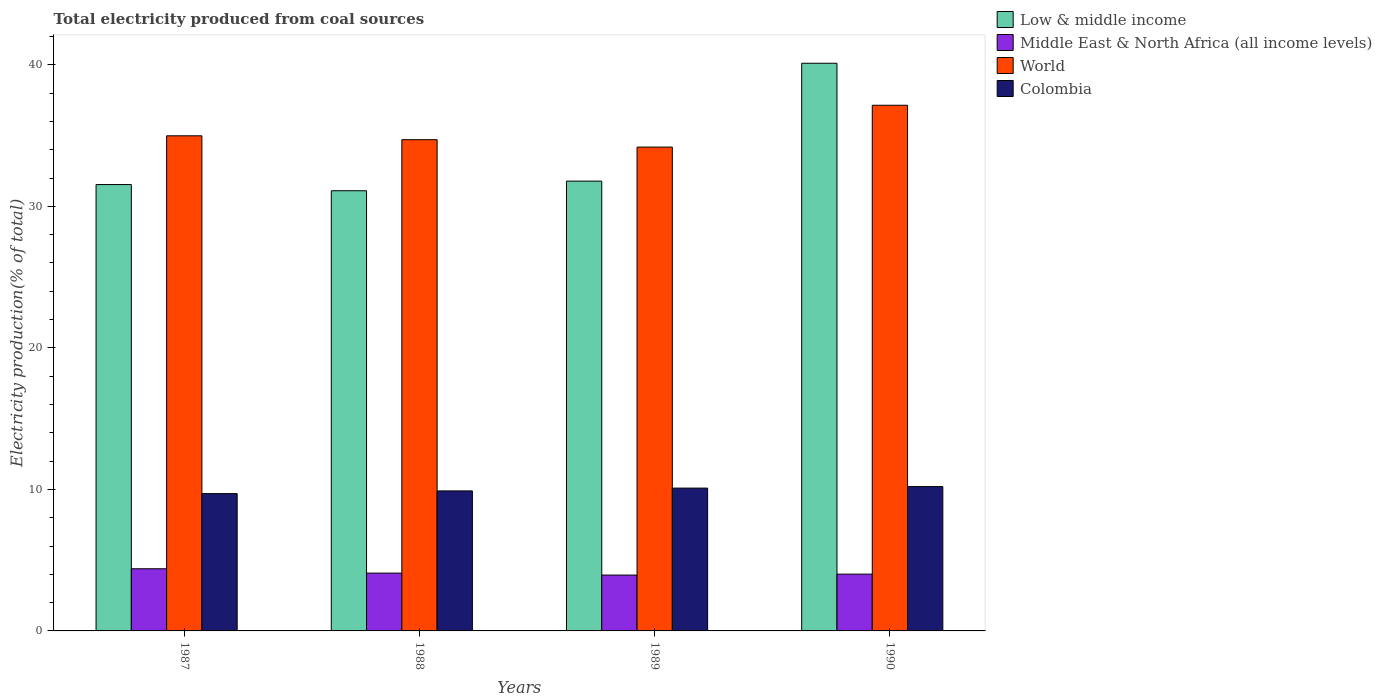Are the number of bars per tick equal to the number of legend labels?
Give a very brief answer. Yes. Are the number of bars on each tick of the X-axis equal?
Your answer should be very brief. Yes. What is the label of the 1st group of bars from the left?
Offer a very short reply. 1987. What is the total electricity produced in Low & middle income in 1990?
Your response must be concise. 40.11. Across all years, what is the maximum total electricity produced in World?
Give a very brief answer. 37.14. Across all years, what is the minimum total electricity produced in World?
Keep it short and to the point. 34.19. In which year was the total electricity produced in World maximum?
Give a very brief answer. 1990. What is the total total electricity produced in World in the graph?
Give a very brief answer. 141.03. What is the difference between the total electricity produced in World in 1988 and that in 1990?
Give a very brief answer. -2.43. What is the difference between the total electricity produced in Middle East & North Africa (all income levels) in 1988 and the total electricity produced in World in 1987?
Your answer should be compact. -30.9. What is the average total electricity produced in World per year?
Provide a short and direct response. 35.26. In the year 1989, what is the difference between the total electricity produced in Middle East & North Africa (all income levels) and total electricity produced in Low & middle income?
Your answer should be compact. -27.84. In how many years, is the total electricity produced in Middle East & North Africa (all income levels) greater than 36 %?
Offer a very short reply. 0. What is the ratio of the total electricity produced in Colombia in 1987 to that in 1989?
Provide a succinct answer. 0.96. Is the total electricity produced in Middle East & North Africa (all income levels) in 1989 less than that in 1990?
Your answer should be very brief. Yes. What is the difference between the highest and the second highest total electricity produced in Colombia?
Offer a very short reply. 0.11. What is the difference between the highest and the lowest total electricity produced in Middle East & North Africa (all income levels)?
Your answer should be very brief. 0.45. Is the sum of the total electricity produced in World in 1989 and 1990 greater than the maximum total electricity produced in Low & middle income across all years?
Provide a succinct answer. Yes. What does the 3rd bar from the left in 1989 represents?
Your answer should be compact. World. What does the 1st bar from the right in 1987 represents?
Your answer should be very brief. Colombia. Does the graph contain any zero values?
Your response must be concise. No. Does the graph contain grids?
Your response must be concise. No. Where does the legend appear in the graph?
Your answer should be very brief. Top right. How are the legend labels stacked?
Ensure brevity in your answer.  Vertical. What is the title of the graph?
Your answer should be compact. Total electricity produced from coal sources. Does "Slovak Republic" appear as one of the legend labels in the graph?
Give a very brief answer. No. What is the label or title of the Y-axis?
Give a very brief answer. Electricity production(% of total). What is the Electricity production(% of total) of Low & middle income in 1987?
Give a very brief answer. 31.54. What is the Electricity production(% of total) in Middle East & North Africa (all income levels) in 1987?
Offer a terse response. 4.39. What is the Electricity production(% of total) in World in 1987?
Offer a very short reply. 34.99. What is the Electricity production(% of total) in Colombia in 1987?
Make the answer very short. 9.7. What is the Electricity production(% of total) in Low & middle income in 1988?
Offer a terse response. 31.1. What is the Electricity production(% of total) in Middle East & North Africa (all income levels) in 1988?
Ensure brevity in your answer.  4.09. What is the Electricity production(% of total) in World in 1988?
Keep it short and to the point. 34.71. What is the Electricity production(% of total) of Colombia in 1988?
Offer a terse response. 9.89. What is the Electricity production(% of total) in Low & middle income in 1989?
Give a very brief answer. 31.78. What is the Electricity production(% of total) of Middle East & North Africa (all income levels) in 1989?
Ensure brevity in your answer.  3.95. What is the Electricity production(% of total) in World in 1989?
Offer a very short reply. 34.19. What is the Electricity production(% of total) in Colombia in 1989?
Make the answer very short. 10.09. What is the Electricity production(% of total) in Low & middle income in 1990?
Your response must be concise. 40.11. What is the Electricity production(% of total) of Middle East & North Africa (all income levels) in 1990?
Your response must be concise. 4.01. What is the Electricity production(% of total) in World in 1990?
Offer a terse response. 37.14. What is the Electricity production(% of total) in Colombia in 1990?
Provide a short and direct response. 10.2. Across all years, what is the maximum Electricity production(% of total) in Low & middle income?
Keep it short and to the point. 40.11. Across all years, what is the maximum Electricity production(% of total) of Middle East & North Africa (all income levels)?
Your response must be concise. 4.39. Across all years, what is the maximum Electricity production(% of total) in World?
Give a very brief answer. 37.14. Across all years, what is the maximum Electricity production(% of total) in Colombia?
Offer a very short reply. 10.2. Across all years, what is the minimum Electricity production(% of total) in Low & middle income?
Provide a short and direct response. 31.1. Across all years, what is the minimum Electricity production(% of total) of Middle East & North Africa (all income levels)?
Provide a succinct answer. 3.95. Across all years, what is the minimum Electricity production(% of total) of World?
Offer a very short reply. 34.19. Across all years, what is the minimum Electricity production(% of total) in Colombia?
Keep it short and to the point. 9.7. What is the total Electricity production(% of total) in Low & middle income in the graph?
Ensure brevity in your answer.  134.54. What is the total Electricity production(% of total) of Middle East & North Africa (all income levels) in the graph?
Give a very brief answer. 16.44. What is the total Electricity production(% of total) of World in the graph?
Make the answer very short. 141.03. What is the total Electricity production(% of total) of Colombia in the graph?
Provide a short and direct response. 39.89. What is the difference between the Electricity production(% of total) of Low & middle income in 1987 and that in 1988?
Keep it short and to the point. 0.44. What is the difference between the Electricity production(% of total) in Middle East & North Africa (all income levels) in 1987 and that in 1988?
Ensure brevity in your answer.  0.31. What is the difference between the Electricity production(% of total) in World in 1987 and that in 1988?
Offer a terse response. 0.27. What is the difference between the Electricity production(% of total) of Colombia in 1987 and that in 1988?
Keep it short and to the point. -0.19. What is the difference between the Electricity production(% of total) in Low & middle income in 1987 and that in 1989?
Provide a short and direct response. -0.24. What is the difference between the Electricity production(% of total) in Middle East & North Africa (all income levels) in 1987 and that in 1989?
Offer a terse response. 0.45. What is the difference between the Electricity production(% of total) of World in 1987 and that in 1989?
Give a very brief answer. 0.8. What is the difference between the Electricity production(% of total) in Colombia in 1987 and that in 1989?
Offer a very short reply. -0.39. What is the difference between the Electricity production(% of total) in Low & middle income in 1987 and that in 1990?
Offer a very short reply. -8.57. What is the difference between the Electricity production(% of total) in Middle East & North Africa (all income levels) in 1987 and that in 1990?
Your answer should be very brief. 0.38. What is the difference between the Electricity production(% of total) of World in 1987 and that in 1990?
Offer a very short reply. -2.16. What is the difference between the Electricity production(% of total) of Colombia in 1987 and that in 1990?
Your answer should be compact. -0.5. What is the difference between the Electricity production(% of total) in Low & middle income in 1988 and that in 1989?
Offer a terse response. -0.68. What is the difference between the Electricity production(% of total) in Middle East & North Africa (all income levels) in 1988 and that in 1989?
Keep it short and to the point. 0.14. What is the difference between the Electricity production(% of total) of World in 1988 and that in 1989?
Your answer should be compact. 0.52. What is the difference between the Electricity production(% of total) in Colombia in 1988 and that in 1989?
Offer a very short reply. -0.2. What is the difference between the Electricity production(% of total) in Low & middle income in 1988 and that in 1990?
Keep it short and to the point. -9.01. What is the difference between the Electricity production(% of total) of Middle East & North Africa (all income levels) in 1988 and that in 1990?
Offer a very short reply. 0.07. What is the difference between the Electricity production(% of total) of World in 1988 and that in 1990?
Offer a very short reply. -2.43. What is the difference between the Electricity production(% of total) in Colombia in 1988 and that in 1990?
Provide a short and direct response. -0.31. What is the difference between the Electricity production(% of total) of Low & middle income in 1989 and that in 1990?
Provide a short and direct response. -8.33. What is the difference between the Electricity production(% of total) of Middle East & North Africa (all income levels) in 1989 and that in 1990?
Offer a very short reply. -0.07. What is the difference between the Electricity production(% of total) in World in 1989 and that in 1990?
Offer a terse response. -2.96. What is the difference between the Electricity production(% of total) of Colombia in 1989 and that in 1990?
Keep it short and to the point. -0.11. What is the difference between the Electricity production(% of total) of Low & middle income in 1987 and the Electricity production(% of total) of Middle East & North Africa (all income levels) in 1988?
Your answer should be compact. 27.46. What is the difference between the Electricity production(% of total) of Low & middle income in 1987 and the Electricity production(% of total) of World in 1988?
Provide a short and direct response. -3.17. What is the difference between the Electricity production(% of total) of Low & middle income in 1987 and the Electricity production(% of total) of Colombia in 1988?
Ensure brevity in your answer.  21.65. What is the difference between the Electricity production(% of total) in Middle East & North Africa (all income levels) in 1987 and the Electricity production(% of total) in World in 1988?
Ensure brevity in your answer.  -30.32. What is the difference between the Electricity production(% of total) of Middle East & North Africa (all income levels) in 1987 and the Electricity production(% of total) of Colombia in 1988?
Your response must be concise. -5.5. What is the difference between the Electricity production(% of total) in World in 1987 and the Electricity production(% of total) in Colombia in 1988?
Keep it short and to the point. 25.09. What is the difference between the Electricity production(% of total) in Low & middle income in 1987 and the Electricity production(% of total) in Middle East & North Africa (all income levels) in 1989?
Give a very brief answer. 27.59. What is the difference between the Electricity production(% of total) in Low & middle income in 1987 and the Electricity production(% of total) in World in 1989?
Ensure brevity in your answer.  -2.65. What is the difference between the Electricity production(% of total) of Low & middle income in 1987 and the Electricity production(% of total) of Colombia in 1989?
Make the answer very short. 21.45. What is the difference between the Electricity production(% of total) in Middle East & North Africa (all income levels) in 1987 and the Electricity production(% of total) in World in 1989?
Provide a succinct answer. -29.8. What is the difference between the Electricity production(% of total) in Middle East & North Africa (all income levels) in 1987 and the Electricity production(% of total) in Colombia in 1989?
Offer a terse response. -5.7. What is the difference between the Electricity production(% of total) in World in 1987 and the Electricity production(% of total) in Colombia in 1989?
Provide a succinct answer. 24.89. What is the difference between the Electricity production(% of total) in Low & middle income in 1987 and the Electricity production(% of total) in Middle East & North Africa (all income levels) in 1990?
Give a very brief answer. 27.53. What is the difference between the Electricity production(% of total) of Low & middle income in 1987 and the Electricity production(% of total) of World in 1990?
Ensure brevity in your answer.  -5.6. What is the difference between the Electricity production(% of total) of Low & middle income in 1987 and the Electricity production(% of total) of Colombia in 1990?
Offer a very short reply. 21.34. What is the difference between the Electricity production(% of total) in Middle East & North Africa (all income levels) in 1987 and the Electricity production(% of total) in World in 1990?
Your response must be concise. -32.75. What is the difference between the Electricity production(% of total) in Middle East & North Africa (all income levels) in 1987 and the Electricity production(% of total) in Colombia in 1990?
Ensure brevity in your answer.  -5.81. What is the difference between the Electricity production(% of total) of World in 1987 and the Electricity production(% of total) of Colombia in 1990?
Keep it short and to the point. 24.79. What is the difference between the Electricity production(% of total) of Low & middle income in 1988 and the Electricity production(% of total) of Middle East & North Africa (all income levels) in 1989?
Your answer should be compact. 27.16. What is the difference between the Electricity production(% of total) in Low & middle income in 1988 and the Electricity production(% of total) in World in 1989?
Your answer should be compact. -3.08. What is the difference between the Electricity production(% of total) in Low & middle income in 1988 and the Electricity production(% of total) in Colombia in 1989?
Keep it short and to the point. 21.01. What is the difference between the Electricity production(% of total) of Middle East & North Africa (all income levels) in 1988 and the Electricity production(% of total) of World in 1989?
Give a very brief answer. -30.1. What is the difference between the Electricity production(% of total) of Middle East & North Africa (all income levels) in 1988 and the Electricity production(% of total) of Colombia in 1989?
Your answer should be very brief. -6.01. What is the difference between the Electricity production(% of total) in World in 1988 and the Electricity production(% of total) in Colombia in 1989?
Provide a succinct answer. 24.62. What is the difference between the Electricity production(% of total) in Low & middle income in 1988 and the Electricity production(% of total) in Middle East & North Africa (all income levels) in 1990?
Give a very brief answer. 27.09. What is the difference between the Electricity production(% of total) in Low & middle income in 1988 and the Electricity production(% of total) in World in 1990?
Give a very brief answer. -6.04. What is the difference between the Electricity production(% of total) of Low & middle income in 1988 and the Electricity production(% of total) of Colombia in 1990?
Your response must be concise. 20.9. What is the difference between the Electricity production(% of total) of Middle East & North Africa (all income levels) in 1988 and the Electricity production(% of total) of World in 1990?
Provide a succinct answer. -33.06. What is the difference between the Electricity production(% of total) of Middle East & North Africa (all income levels) in 1988 and the Electricity production(% of total) of Colombia in 1990?
Your answer should be very brief. -6.11. What is the difference between the Electricity production(% of total) in World in 1988 and the Electricity production(% of total) in Colombia in 1990?
Offer a very short reply. 24.51. What is the difference between the Electricity production(% of total) in Low & middle income in 1989 and the Electricity production(% of total) in Middle East & North Africa (all income levels) in 1990?
Your answer should be compact. 27.77. What is the difference between the Electricity production(% of total) of Low & middle income in 1989 and the Electricity production(% of total) of World in 1990?
Make the answer very short. -5.36. What is the difference between the Electricity production(% of total) of Low & middle income in 1989 and the Electricity production(% of total) of Colombia in 1990?
Offer a terse response. 21.58. What is the difference between the Electricity production(% of total) in Middle East & North Africa (all income levels) in 1989 and the Electricity production(% of total) in World in 1990?
Your response must be concise. -33.2. What is the difference between the Electricity production(% of total) of Middle East & North Africa (all income levels) in 1989 and the Electricity production(% of total) of Colombia in 1990?
Offer a terse response. -6.25. What is the difference between the Electricity production(% of total) of World in 1989 and the Electricity production(% of total) of Colombia in 1990?
Your response must be concise. 23.99. What is the average Electricity production(% of total) of Low & middle income per year?
Provide a succinct answer. 33.63. What is the average Electricity production(% of total) of Middle East & North Africa (all income levels) per year?
Your answer should be compact. 4.11. What is the average Electricity production(% of total) in World per year?
Provide a short and direct response. 35.26. What is the average Electricity production(% of total) in Colombia per year?
Your answer should be very brief. 9.97. In the year 1987, what is the difference between the Electricity production(% of total) of Low & middle income and Electricity production(% of total) of Middle East & North Africa (all income levels)?
Provide a short and direct response. 27.15. In the year 1987, what is the difference between the Electricity production(% of total) in Low & middle income and Electricity production(% of total) in World?
Keep it short and to the point. -3.44. In the year 1987, what is the difference between the Electricity production(% of total) of Low & middle income and Electricity production(% of total) of Colombia?
Offer a very short reply. 21.84. In the year 1987, what is the difference between the Electricity production(% of total) in Middle East & North Africa (all income levels) and Electricity production(% of total) in World?
Your answer should be very brief. -30.59. In the year 1987, what is the difference between the Electricity production(% of total) of Middle East & North Africa (all income levels) and Electricity production(% of total) of Colombia?
Your answer should be compact. -5.31. In the year 1987, what is the difference between the Electricity production(% of total) of World and Electricity production(% of total) of Colombia?
Your answer should be very brief. 25.28. In the year 1988, what is the difference between the Electricity production(% of total) of Low & middle income and Electricity production(% of total) of Middle East & North Africa (all income levels)?
Make the answer very short. 27.02. In the year 1988, what is the difference between the Electricity production(% of total) in Low & middle income and Electricity production(% of total) in World?
Your response must be concise. -3.61. In the year 1988, what is the difference between the Electricity production(% of total) in Low & middle income and Electricity production(% of total) in Colombia?
Offer a terse response. 21.21. In the year 1988, what is the difference between the Electricity production(% of total) of Middle East & North Africa (all income levels) and Electricity production(% of total) of World?
Ensure brevity in your answer.  -30.63. In the year 1988, what is the difference between the Electricity production(% of total) of Middle East & North Africa (all income levels) and Electricity production(% of total) of Colombia?
Provide a succinct answer. -5.81. In the year 1988, what is the difference between the Electricity production(% of total) of World and Electricity production(% of total) of Colombia?
Provide a succinct answer. 24.82. In the year 1989, what is the difference between the Electricity production(% of total) in Low & middle income and Electricity production(% of total) in Middle East & North Africa (all income levels)?
Ensure brevity in your answer.  27.84. In the year 1989, what is the difference between the Electricity production(% of total) in Low & middle income and Electricity production(% of total) in World?
Ensure brevity in your answer.  -2.4. In the year 1989, what is the difference between the Electricity production(% of total) in Low & middle income and Electricity production(% of total) in Colombia?
Ensure brevity in your answer.  21.69. In the year 1989, what is the difference between the Electricity production(% of total) of Middle East & North Africa (all income levels) and Electricity production(% of total) of World?
Give a very brief answer. -30.24. In the year 1989, what is the difference between the Electricity production(% of total) of Middle East & North Africa (all income levels) and Electricity production(% of total) of Colombia?
Offer a very short reply. -6.15. In the year 1989, what is the difference between the Electricity production(% of total) of World and Electricity production(% of total) of Colombia?
Provide a succinct answer. 24.1. In the year 1990, what is the difference between the Electricity production(% of total) of Low & middle income and Electricity production(% of total) of Middle East & North Africa (all income levels)?
Give a very brief answer. 36.1. In the year 1990, what is the difference between the Electricity production(% of total) of Low & middle income and Electricity production(% of total) of World?
Provide a succinct answer. 2.97. In the year 1990, what is the difference between the Electricity production(% of total) of Low & middle income and Electricity production(% of total) of Colombia?
Give a very brief answer. 29.91. In the year 1990, what is the difference between the Electricity production(% of total) of Middle East & North Africa (all income levels) and Electricity production(% of total) of World?
Make the answer very short. -33.13. In the year 1990, what is the difference between the Electricity production(% of total) in Middle East & North Africa (all income levels) and Electricity production(% of total) in Colombia?
Make the answer very short. -6.19. In the year 1990, what is the difference between the Electricity production(% of total) in World and Electricity production(% of total) in Colombia?
Offer a very short reply. 26.94. What is the ratio of the Electricity production(% of total) in Low & middle income in 1987 to that in 1988?
Make the answer very short. 1.01. What is the ratio of the Electricity production(% of total) of Middle East & North Africa (all income levels) in 1987 to that in 1988?
Your answer should be compact. 1.08. What is the ratio of the Electricity production(% of total) of World in 1987 to that in 1988?
Make the answer very short. 1.01. What is the ratio of the Electricity production(% of total) of Colombia in 1987 to that in 1988?
Your answer should be compact. 0.98. What is the ratio of the Electricity production(% of total) in Low & middle income in 1987 to that in 1989?
Keep it short and to the point. 0.99. What is the ratio of the Electricity production(% of total) in Middle East & North Africa (all income levels) in 1987 to that in 1989?
Your response must be concise. 1.11. What is the ratio of the Electricity production(% of total) in World in 1987 to that in 1989?
Keep it short and to the point. 1.02. What is the ratio of the Electricity production(% of total) in Colombia in 1987 to that in 1989?
Make the answer very short. 0.96. What is the ratio of the Electricity production(% of total) of Low & middle income in 1987 to that in 1990?
Make the answer very short. 0.79. What is the ratio of the Electricity production(% of total) in Middle East & North Africa (all income levels) in 1987 to that in 1990?
Make the answer very short. 1.09. What is the ratio of the Electricity production(% of total) of World in 1987 to that in 1990?
Make the answer very short. 0.94. What is the ratio of the Electricity production(% of total) of Colombia in 1987 to that in 1990?
Provide a succinct answer. 0.95. What is the ratio of the Electricity production(% of total) in Low & middle income in 1988 to that in 1989?
Make the answer very short. 0.98. What is the ratio of the Electricity production(% of total) in Middle East & North Africa (all income levels) in 1988 to that in 1989?
Your response must be concise. 1.04. What is the ratio of the Electricity production(% of total) in World in 1988 to that in 1989?
Offer a very short reply. 1.02. What is the ratio of the Electricity production(% of total) of Colombia in 1988 to that in 1989?
Ensure brevity in your answer.  0.98. What is the ratio of the Electricity production(% of total) of Low & middle income in 1988 to that in 1990?
Offer a terse response. 0.78. What is the ratio of the Electricity production(% of total) in Middle East & North Africa (all income levels) in 1988 to that in 1990?
Your response must be concise. 1.02. What is the ratio of the Electricity production(% of total) in World in 1988 to that in 1990?
Make the answer very short. 0.93. What is the ratio of the Electricity production(% of total) of Low & middle income in 1989 to that in 1990?
Give a very brief answer. 0.79. What is the ratio of the Electricity production(% of total) in Middle East & North Africa (all income levels) in 1989 to that in 1990?
Offer a very short reply. 0.98. What is the ratio of the Electricity production(% of total) of World in 1989 to that in 1990?
Offer a very short reply. 0.92. What is the ratio of the Electricity production(% of total) in Colombia in 1989 to that in 1990?
Offer a terse response. 0.99. What is the difference between the highest and the second highest Electricity production(% of total) of Low & middle income?
Provide a short and direct response. 8.33. What is the difference between the highest and the second highest Electricity production(% of total) in Middle East & North Africa (all income levels)?
Provide a short and direct response. 0.31. What is the difference between the highest and the second highest Electricity production(% of total) in World?
Make the answer very short. 2.16. What is the difference between the highest and the second highest Electricity production(% of total) of Colombia?
Your response must be concise. 0.11. What is the difference between the highest and the lowest Electricity production(% of total) of Low & middle income?
Your answer should be very brief. 9.01. What is the difference between the highest and the lowest Electricity production(% of total) of Middle East & North Africa (all income levels)?
Your answer should be very brief. 0.45. What is the difference between the highest and the lowest Electricity production(% of total) of World?
Offer a terse response. 2.96. What is the difference between the highest and the lowest Electricity production(% of total) in Colombia?
Your answer should be very brief. 0.5. 